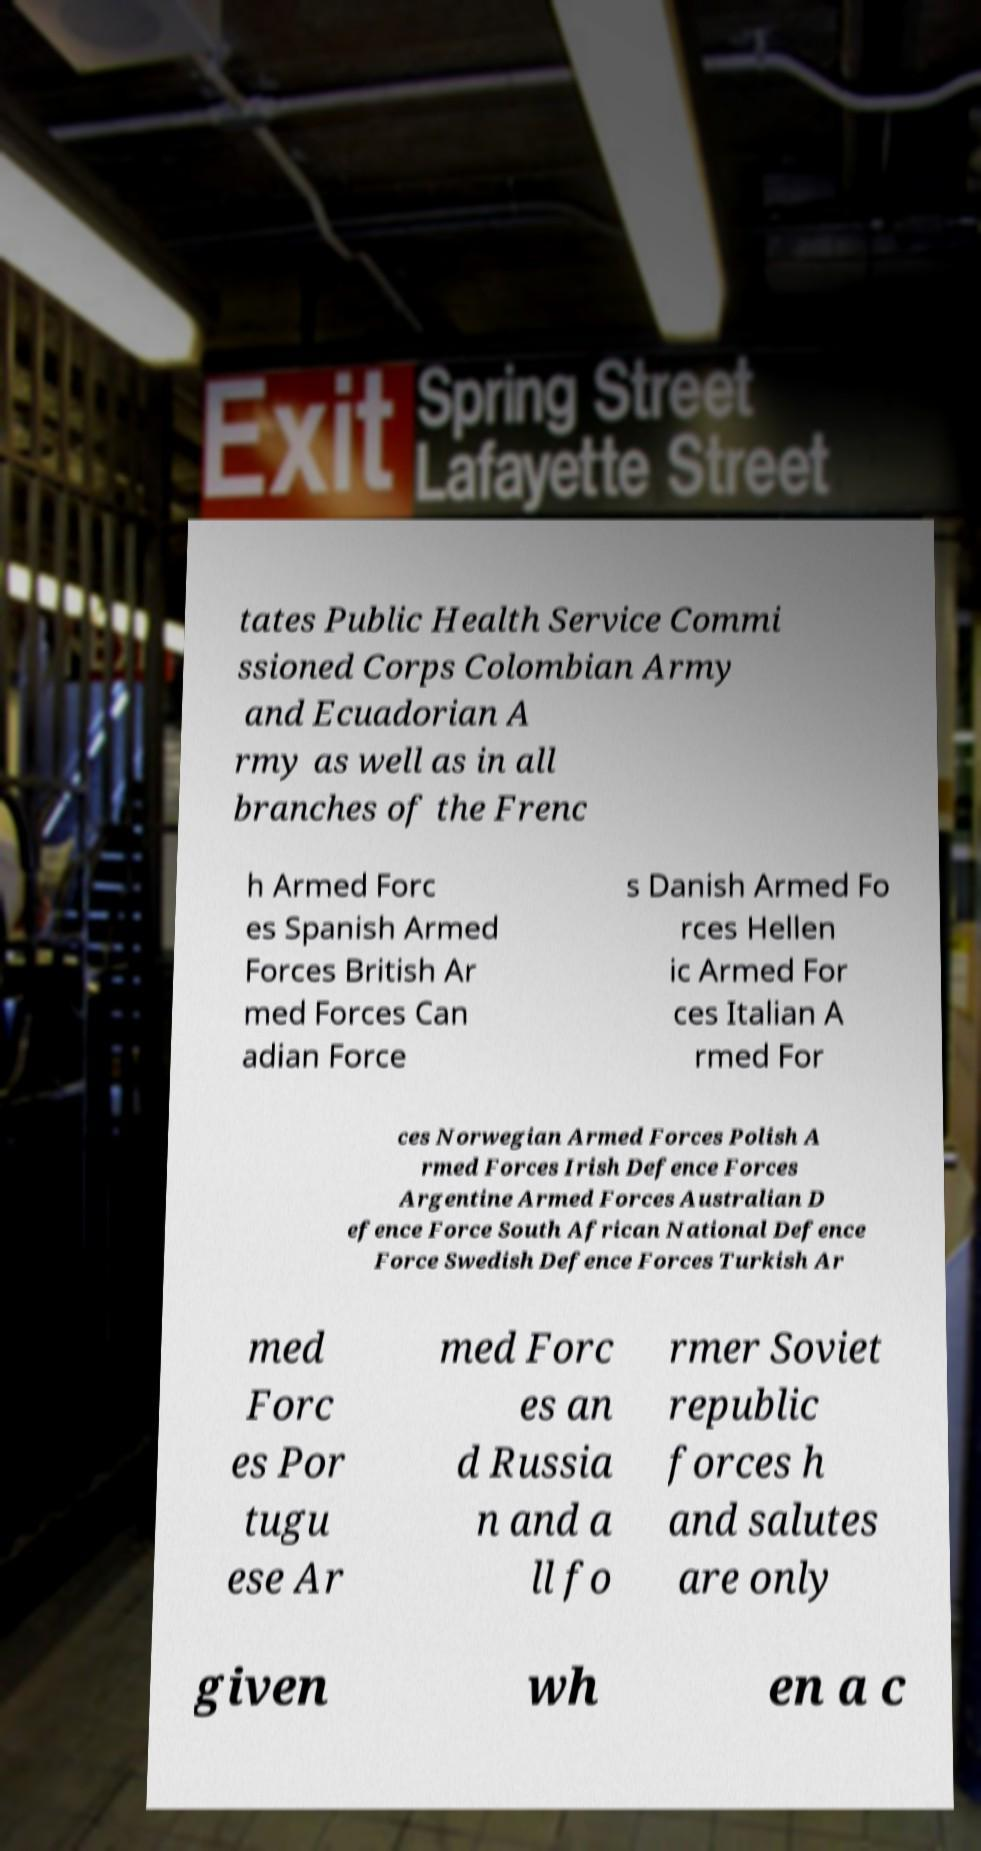Can you read and provide the text displayed in the image?This photo seems to have some interesting text. Can you extract and type it out for me? tates Public Health Service Commi ssioned Corps Colombian Army and Ecuadorian A rmy as well as in all branches of the Frenc h Armed Forc es Spanish Armed Forces British Ar med Forces Can adian Force s Danish Armed Fo rces Hellen ic Armed For ces Italian A rmed For ces Norwegian Armed Forces Polish A rmed Forces Irish Defence Forces Argentine Armed Forces Australian D efence Force South African National Defence Force Swedish Defence Forces Turkish Ar med Forc es Por tugu ese Ar med Forc es an d Russia n and a ll fo rmer Soviet republic forces h and salutes are only given wh en a c 